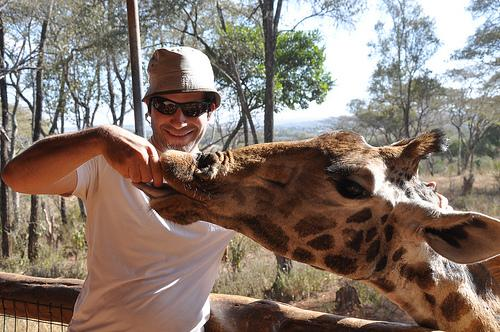Find a multi-choice question related to the giraffe's tongue and create four possible answers. d. It's used to hold the man's hat Give a description of the man that includes different parts of his attire and their colors.  The man can be seen wearing a white t-shirt, a small tan hat, and fashionable black sunglasses while interacting with the giraffe. Describe a possible backstory for the man wearing black sunglasses in this image. The man, an animal enthusiast on vacation, couldn't resist getting close and capturing a special moment with the giraffe, while wearing his protective and stylish black sunglasses. Choose a referential expression for the green leaves on the tree and describe them. The lush green foliage on the tree creates a fresh, vibrant atmosphere as it spreads its branches out. Name an entailed scenario between the man and the giraffe based on the man's action. The man could be a brave zookeeper or a curious tourist, attempting to feed or play with the giraffe by putting his finger in its mouth. Create an advertisement tagline for this image to promote a sunglasses brand. Keep your cool while exploring the wild - try our stylish black sunglasses, perfect for unforgettable adventures. Briefly describe the giraffe and its surrounding environment in the image. The giraffe has a large head with white and brown spots, captivating eyes and ears, and its tongue is out. It's surrounded by a tall, leafy green tree and a fence. Connect the tall tree in the back to an environmental campaign message. Let's keep our trees as tall and healthy as the ones in the back of this beautiful image. Protect our forests, start your eco-friendly change today! Write a short narrative on the interaction between the man and the giraffe. A man wearing a white shirt, a tan hat, and black sunglasses is having a unique moment with a giraffe, as he puts his fingers in the giraffe's mouth, and the giraffe playfully sticks out its tongue. What type of question could you ask about the man's attire in the image? What color is the man's t-shirt, and what type of hat is he wearing? 